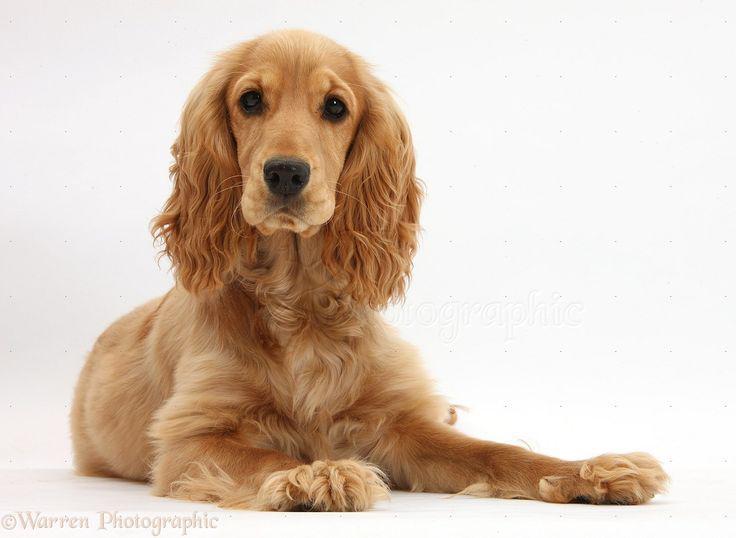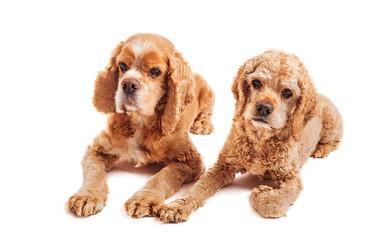The first image is the image on the left, the second image is the image on the right. Assess this claim about the two images: "The dog in one of the images is looking straight into the camera.". Correct or not? Answer yes or no. Yes. 